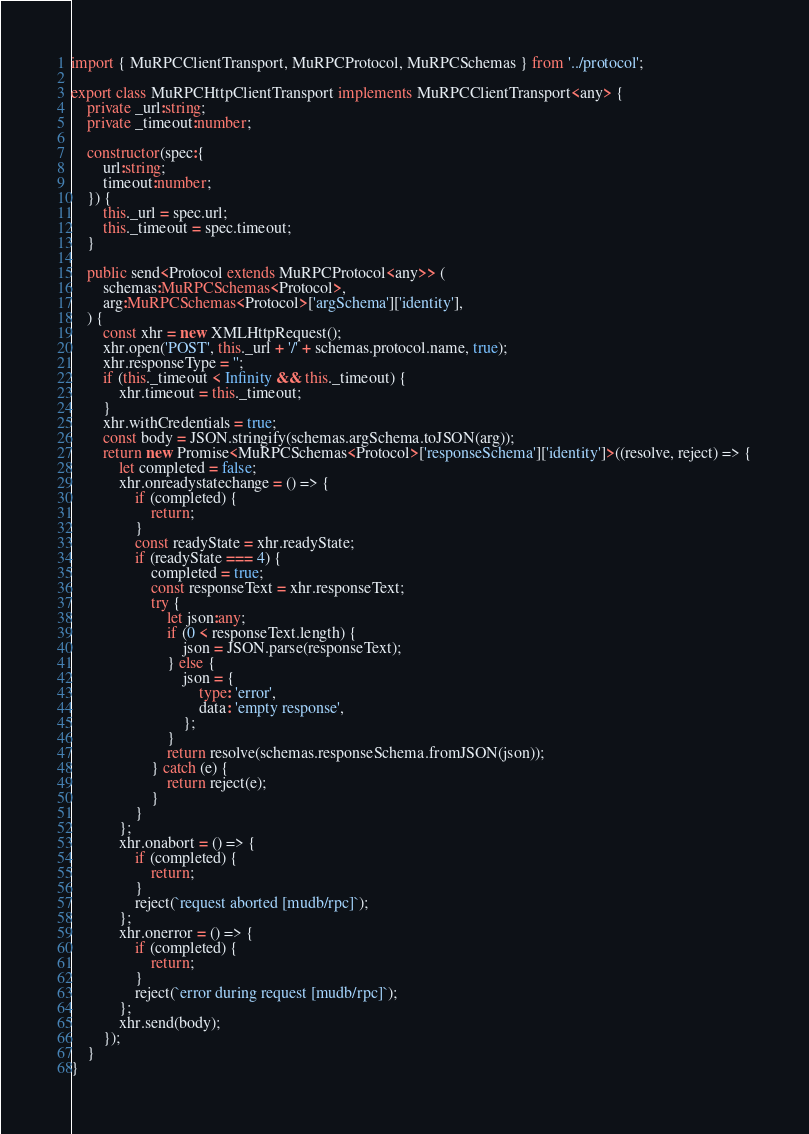<code> <loc_0><loc_0><loc_500><loc_500><_TypeScript_>import { MuRPCClientTransport, MuRPCProtocol, MuRPCSchemas } from '../protocol';

export class MuRPCHttpClientTransport implements MuRPCClientTransport<any> {
    private _url:string;
    private _timeout:number;

    constructor(spec:{
        url:string;
        timeout:number;
    }) {
        this._url = spec.url;
        this._timeout = spec.timeout;
    }

    public send<Protocol extends MuRPCProtocol<any>> (
        schemas:MuRPCSchemas<Protocol>,
        arg:MuRPCSchemas<Protocol>['argSchema']['identity'],
    ) {
        const xhr = new XMLHttpRequest();
        xhr.open('POST', this._url + '/' + schemas.protocol.name, true);
        xhr.responseType = '';
        if (this._timeout < Infinity && this._timeout) {
            xhr.timeout = this._timeout;
        }
        xhr.withCredentials = true;
        const body = JSON.stringify(schemas.argSchema.toJSON(arg));
        return new Promise<MuRPCSchemas<Protocol>['responseSchema']['identity']>((resolve, reject) => {
            let completed = false;
            xhr.onreadystatechange = () => {
                if (completed) {
                    return;
                }
                const readyState = xhr.readyState;
                if (readyState === 4) {
                    completed = true;
                    const responseText = xhr.responseText;
                    try {
                        let json:any;
                        if (0 < responseText.length) {
                            json = JSON.parse(responseText);
                        } else {
                            json = {
                                type: 'error',
                                data: 'empty response',
                            };
                        }
                        return resolve(schemas.responseSchema.fromJSON(json));
                    } catch (e) {
                        return reject(e);
                    }
                }
            };
            xhr.onabort = () => {
                if (completed) {
                    return;
                }
                reject(`request aborted [mudb/rpc]`);
            };
            xhr.onerror = () => {
                if (completed) {
                    return;
                }
                reject(`error during request [mudb/rpc]`);
            };
            xhr.send(body);
        });
    }
}
</code> 